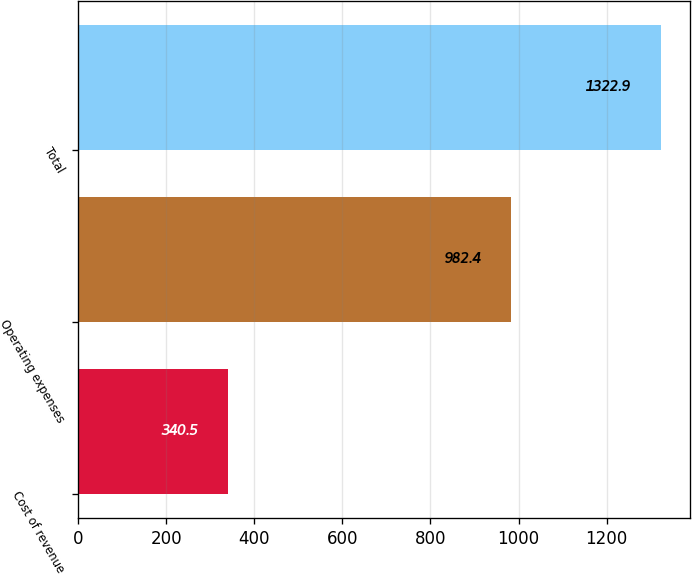<chart> <loc_0><loc_0><loc_500><loc_500><bar_chart><fcel>Cost of revenue<fcel>Operating expenses<fcel>Total<nl><fcel>340.5<fcel>982.4<fcel>1322.9<nl></chart> 